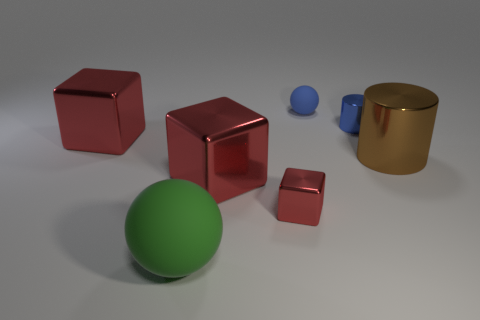How many red blocks must be subtracted to get 1 red blocks? 2 Add 3 tiny green balls. How many objects exist? 10 Subtract all cylinders. How many objects are left? 5 Add 7 tiny shiny things. How many tiny shiny things exist? 9 Subtract 0 purple spheres. How many objects are left? 7 Subtract all tiny gray rubber cylinders. Subtract all tiny metal cylinders. How many objects are left? 6 Add 5 red blocks. How many red blocks are left? 8 